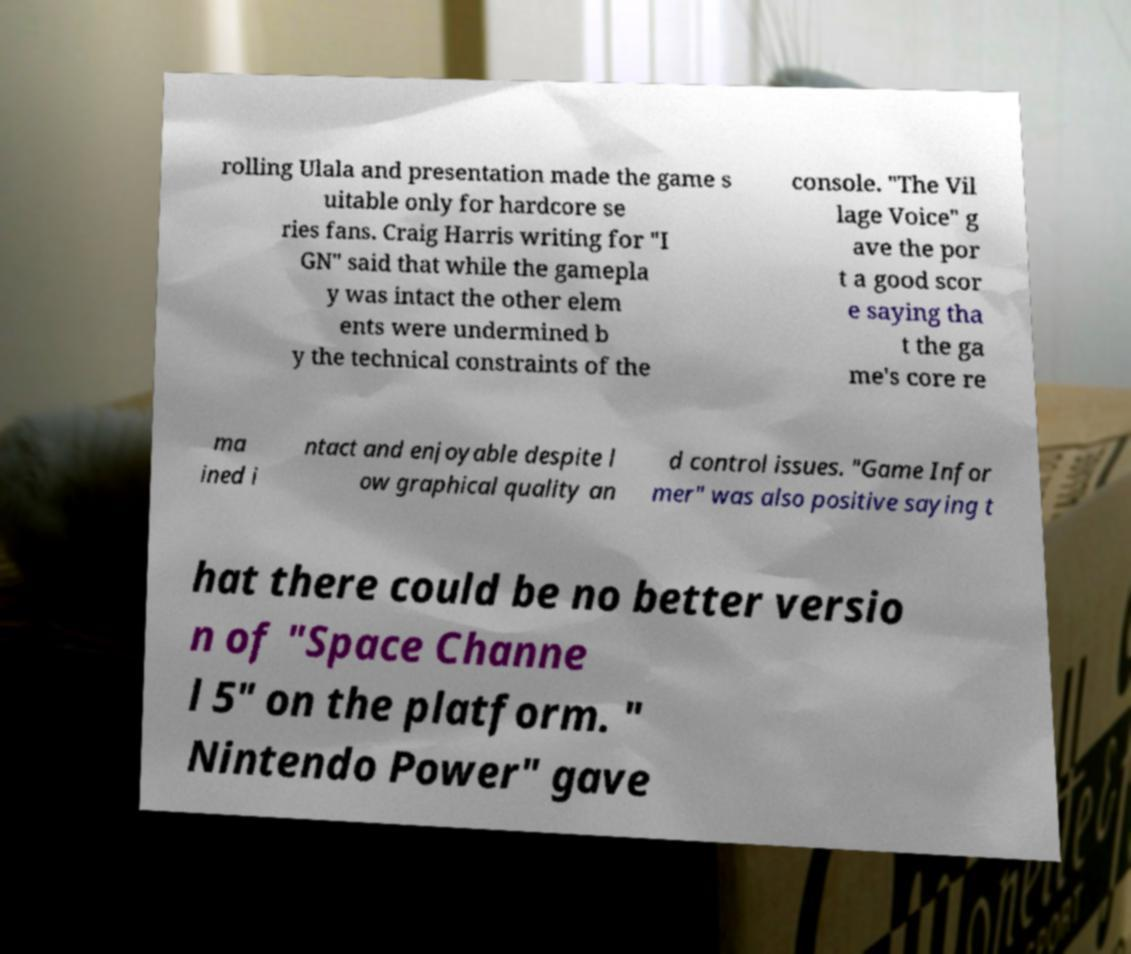There's text embedded in this image that I need extracted. Can you transcribe it verbatim? rolling Ulala and presentation made the game s uitable only for hardcore se ries fans. Craig Harris writing for "I GN" said that while the gamepla y was intact the other elem ents were undermined b y the technical constraints of the console. "The Vil lage Voice" g ave the por t a good scor e saying tha t the ga me's core re ma ined i ntact and enjoyable despite l ow graphical quality an d control issues. "Game Infor mer" was also positive saying t hat there could be no better versio n of "Space Channe l 5" on the platform. " Nintendo Power" gave 